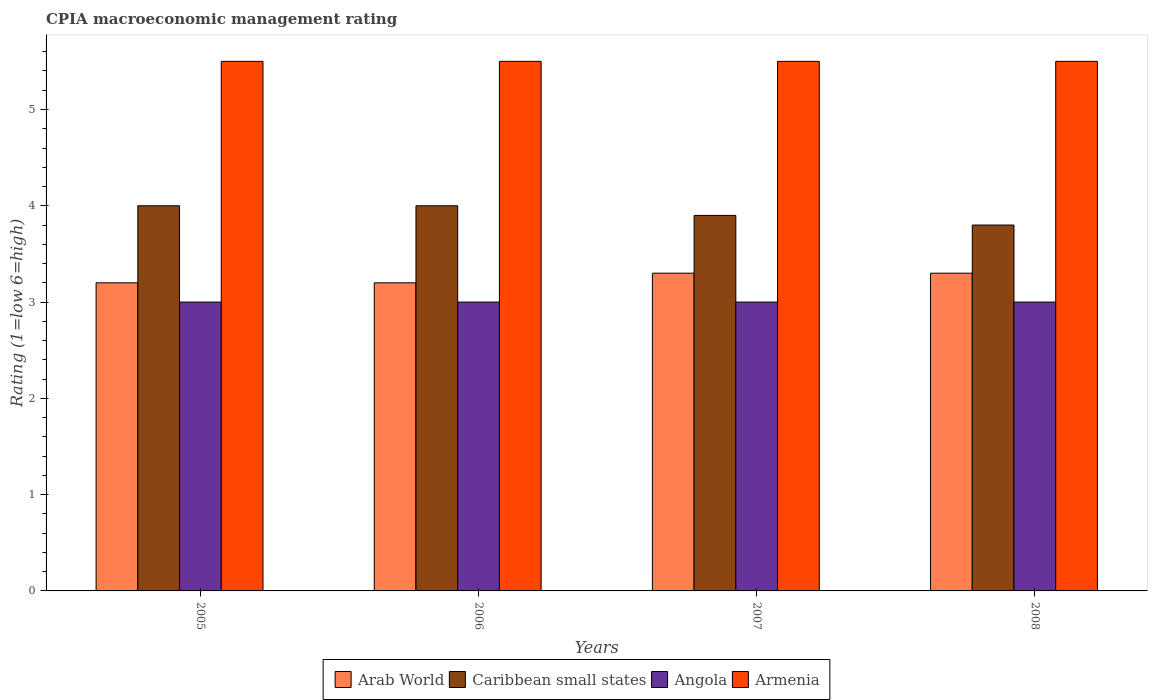How many groups of bars are there?
Your answer should be compact. 4. In which year was the CPIA rating in Caribbean small states minimum?
Your response must be concise. 2008. What is the total CPIA rating in Armenia in the graph?
Your answer should be very brief. 22. What is the difference between the CPIA rating in Angola in 2007 and the CPIA rating in Caribbean small states in 2008?
Keep it short and to the point. -0.8. What is the difference between the highest and the lowest CPIA rating in Caribbean small states?
Provide a short and direct response. 0.2. In how many years, is the CPIA rating in Armenia greater than the average CPIA rating in Armenia taken over all years?
Provide a short and direct response. 0. What does the 1st bar from the left in 2008 represents?
Ensure brevity in your answer.  Arab World. What does the 1st bar from the right in 2006 represents?
Make the answer very short. Armenia. Is it the case that in every year, the sum of the CPIA rating in Caribbean small states and CPIA rating in Arab World is greater than the CPIA rating in Armenia?
Your answer should be very brief. Yes. Are the values on the major ticks of Y-axis written in scientific E-notation?
Give a very brief answer. No. Does the graph contain any zero values?
Provide a succinct answer. No. Does the graph contain grids?
Your answer should be very brief. No. How are the legend labels stacked?
Provide a short and direct response. Horizontal. What is the title of the graph?
Offer a very short reply. CPIA macroeconomic management rating. Does "Philippines" appear as one of the legend labels in the graph?
Your answer should be compact. No. What is the label or title of the X-axis?
Your response must be concise. Years. What is the Rating (1=low 6=high) in Arab World in 2005?
Ensure brevity in your answer.  3.2. What is the Rating (1=low 6=high) of Caribbean small states in 2005?
Ensure brevity in your answer.  4. What is the Rating (1=low 6=high) of Angola in 2005?
Provide a succinct answer. 3. What is the Rating (1=low 6=high) of Armenia in 2005?
Your answer should be very brief. 5.5. What is the Rating (1=low 6=high) in Caribbean small states in 2006?
Provide a succinct answer. 4. What is the Rating (1=low 6=high) of Armenia in 2006?
Your response must be concise. 5.5. What is the Rating (1=low 6=high) of Arab World in 2007?
Your response must be concise. 3.3. What is the Rating (1=low 6=high) of Angola in 2007?
Your answer should be compact. 3. What is the Rating (1=low 6=high) of Arab World in 2008?
Keep it short and to the point. 3.3. What is the Rating (1=low 6=high) in Caribbean small states in 2008?
Offer a terse response. 3.8. What is the Rating (1=low 6=high) of Angola in 2008?
Provide a short and direct response. 3. What is the Rating (1=low 6=high) in Armenia in 2008?
Provide a succinct answer. 5.5. Across all years, what is the maximum Rating (1=low 6=high) in Caribbean small states?
Your answer should be very brief. 4. Across all years, what is the minimum Rating (1=low 6=high) of Angola?
Give a very brief answer. 3. Across all years, what is the minimum Rating (1=low 6=high) in Armenia?
Your answer should be very brief. 5.5. What is the total Rating (1=low 6=high) in Arab World in the graph?
Offer a very short reply. 13. What is the total Rating (1=low 6=high) in Caribbean small states in the graph?
Ensure brevity in your answer.  15.7. What is the total Rating (1=low 6=high) of Angola in the graph?
Make the answer very short. 12. What is the difference between the Rating (1=low 6=high) in Arab World in 2005 and that in 2006?
Provide a succinct answer. 0. What is the difference between the Rating (1=low 6=high) in Caribbean small states in 2005 and that in 2006?
Make the answer very short. 0. What is the difference between the Rating (1=low 6=high) in Arab World in 2005 and that in 2007?
Give a very brief answer. -0.1. What is the difference between the Rating (1=low 6=high) in Arab World in 2005 and that in 2008?
Offer a terse response. -0.1. What is the difference between the Rating (1=low 6=high) in Caribbean small states in 2005 and that in 2008?
Your answer should be very brief. 0.2. What is the difference between the Rating (1=low 6=high) of Arab World in 2006 and that in 2007?
Give a very brief answer. -0.1. What is the difference between the Rating (1=low 6=high) of Caribbean small states in 2006 and that in 2008?
Offer a very short reply. 0.2. What is the difference between the Rating (1=low 6=high) in Angola in 2006 and that in 2008?
Ensure brevity in your answer.  0. What is the difference between the Rating (1=low 6=high) of Armenia in 2006 and that in 2008?
Keep it short and to the point. 0. What is the difference between the Rating (1=low 6=high) of Arab World in 2007 and that in 2008?
Your response must be concise. 0. What is the difference between the Rating (1=low 6=high) in Arab World in 2005 and the Rating (1=low 6=high) in Caribbean small states in 2006?
Provide a short and direct response. -0.8. What is the difference between the Rating (1=low 6=high) of Arab World in 2005 and the Rating (1=low 6=high) of Armenia in 2006?
Offer a very short reply. -2.3. What is the difference between the Rating (1=low 6=high) of Arab World in 2005 and the Rating (1=low 6=high) of Caribbean small states in 2007?
Provide a succinct answer. -0.7. What is the difference between the Rating (1=low 6=high) in Caribbean small states in 2005 and the Rating (1=low 6=high) in Angola in 2007?
Keep it short and to the point. 1. What is the difference between the Rating (1=low 6=high) of Caribbean small states in 2005 and the Rating (1=low 6=high) of Armenia in 2008?
Your answer should be very brief. -1.5. What is the difference between the Rating (1=low 6=high) of Caribbean small states in 2006 and the Rating (1=low 6=high) of Armenia in 2007?
Ensure brevity in your answer.  -1.5. What is the difference between the Rating (1=low 6=high) of Arab World in 2006 and the Rating (1=low 6=high) of Angola in 2008?
Provide a short and direct response. 0.2. What is the difference between the Rating (1=low 6=high) of Caribbean small states in 2006 and the Rating (1=low 6=high) of Angola in 2008?
Your answer should be very brief. 1. What is the difference between the Rating (1=low 6=high) of Caribbean small states in 2006 and the Rating (1=low 6=high) of Armenia in 2008?
Make the answer very short. -1.5. What is the difference between the Rating (1=low 6=high) in Arab World in 2007 and the Rating (1=low 6=high) in Angola in 2008?
Provide a short and direct response. 0.3. What is the difference between the Rating (1=low 6=high) of Arab World in 2007 and the Rating (1=low 6=high) of Armenia in 2008?
Provide a short and direct response. -2.2. What is the difference between the Rating (1=low 6=high) of Caribbean small states in 2007 and the Rating (1=low 6=high) of Armenia in 2008?
Provide a short and direct response. -1.6. What is the average Rating (1=low 6=high) in Caribbean small states per year?
Your answer should be compact. 3.92. What is the average Rating (1=low 6=high) in Armenia per year?
Offer a very short reply. 5.5. In the year 2005, what is the difference between the Rating (1=low 6=high) of Arab World and Rating (1=low 6=high) of Angola?
Make the answer very short. 0.2. In the year 2005, what is the difference between the Rating (1=low 6=high) of Arab World and Rating (1=low 6=high) of Armenia?
Your answer should be very brief. -2.3. In the year 2005, what is the difference between the Rating (1=low 6=high) in Angola and Rating (1=low 6=high) in Armenia?
Offer a terse response. -2.5. In the year 2006, what is the difference between the Rating (1=low 6=high) in Arab World and Rating (1=low 6=high) in Caribbean small states?
Ensure brevity in your answer.  -0.8. In the year 2006, what is the difference between the Rating (1=low 6=high) in Arab World and Rating (1=low 6=high) in Angola?
Your response must be concise. 0.2. In the year 2006, what is the difference between the Rating (1=low 6=high) of Arab World and Rating (1=low 6=high) of Armenia?
Provide a succinct answer. -2.3. In the year 2006, what is the difference between the Rating (1=low 6=high) of Caribbean small states and Rating (1=low 6=high) of Armenia?
Offer a very short reply. -1.5. In the year 2007, what is the difference between the Rating (1=low 6=high) in Arab World and Rating (1=low 6=high) in Angola?
Your answer should be very brief. 0.3. In the year 2007, what is the difference between the Rating (1=low 6=high) in Arab World and Rating (1=low 6=high) in Armenia?
Offer a very short reply. -2.2. In the year 2007, what is the difference between the Rating (1=low 6=high) of Caribbean small states and Rating (1=low 6=high) of Angola?
Give a very brief answer. 0.9. In the year 2007, what is the difference between the Rating (1=low 6=high) of Caribbean small states and Rating (1=low 6=high) of Armenia?
Offer a very short reply. -1.6. In the year 2007, what is the difference between the Rating (1=low 6=high) in Angola and Rating (1=low 6=high) in Armenia?
Offer a terse response. -2.5. In the year 2008, what is the difference between the Rating (1=low 6=high) of Arab World and Rating (1=low 6=high) of Armenia?
Provide a succinct answer. -2.2. In the year 2008, what is the difference between the Rating (1=low 6=high) in Caribbean small states and Rating (1=low 6=high) in Armenia?
Give a very brief answer. -1.7. What is the ratio of the Rating (1=low 6=high) in Caribbean small states in 2005 to that in 2006?
Give a very brief answer. 1. What is the ratio of the Rating (1=low 6=high) in Angola in 2005 to that in 2006?
Your answer should be very brief. 1. What is the ratio of the Rating (1=low 6=high) of Arab World in 2005 to that in 2007?
Ensure brevity in your answer.  0.97. What is the ratio of the Rating (1=low 6=high) of Caribbean small states in 2005 to that in 2007?
Give a very brief answer. 1.03. What is the ratio of the Rating (1=low 6=high) of Angola in 2005 to that in 2007?
Your answer should be compact. 1. What is the ratio of the Rating (1=low 6=high) of Armenia in 2005 to that in 2007?
Offer a terse response. 1. What is the ratio of the Rating (1=low 6=high) in Arab World in 2005 to that in 2008?
Your answer should be very brief. 0.97. What is the ratio of the Rating (1=low 6=high) in Caribbean small states in 2005 to that in 2008?
Keep it short and to the point. 1.05. What is the ratio of the Rating (1=low 6=high) of Angola in 2005 to that in 2008?
Make the answer very short. 1. What is the ratio of the Rating (1=low 6=high) in Arab World in 2006 to that in 2007?
Provide a short and direct response. 0.97. What is the ratio of the Rating (1=low 6=high) of Caribbean small states in 2006 to that in 2007?
Offer a terse response. 1.03. What is the ratio of the Rating (1=low 6=high) in Angola in 2006 to that in 2007?
Provide a succinct answer. 1. What is the ratio of the Rating (1=low 6=high) of Arab World in 2006 to that in 2008?
Give a very brief answer. 0.97. What is the ratio of the Rating (1=low 6=high) of Caribbean small states in 2006 to that in 2008?
Make the answer very short. 1.05. What is the ratio of the Rating (1=low 6=high) in Arab World in 2007 to that in 2008?
Give a very brief answer. 1. What is the ratio of the Rating (1=low 6=high) in Caribbean small states in 2007 to that in 2008?
Provide a succinct answer. 1.03. What is the ratio of the Rating (1=low 6=high) in Angola in 2007 to that in 2008?
Offer a very short reply. 1. What is the ratio of the Rating (1=low 6=high) of Armenia in 2007 to that in 2008?
Offer a very short reply. 1. What is the difference between the highest and the second highest Rating (1=low 6=high) of Arab World?
Provide a succinct answer. 0. What is the difference between the highest and the second highest Rating (1=low 6=high) of Caribbean small states?
Your response must be concise. 0. What is the difference between the highest and the second highest Rating (1=low 6=high) in Angola?
Offer a very short reply. 0. What is the difference between the highest and the second highest Rating (1=low 6=high) in Armenia?
Ensure brevity in your answer.  0. What is the difference between the highest and the lowest Rating (1=low 6=high) of Arab World?
Your response must be concise. 0.1. 